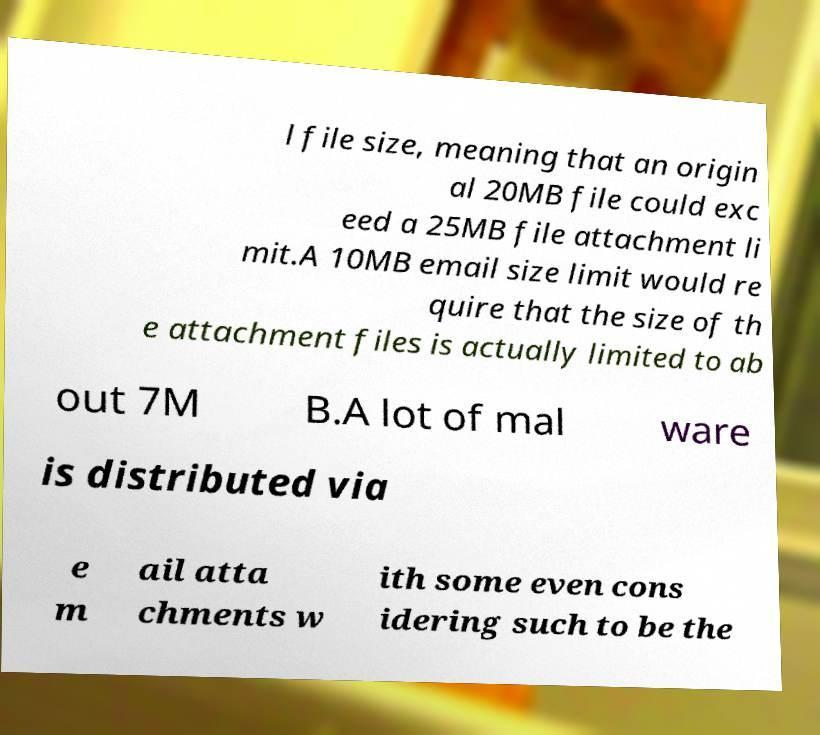Please read and relay the text visible in this image. What does it say? l file size, meaning that an origin al 20MB file could exc eed a 25MB file attachment li mit.A 10MB email size limit would re quire that the size of th e attachment files is actually limited to ab out 7M B.A lot of mal ware is distributed via e m ail atta chments w ith some even cons idering such to be the 